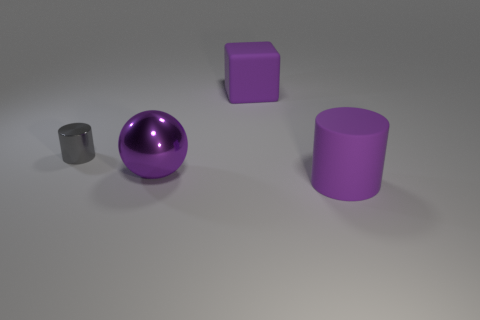How many objects are there, and can you describe their shapes? There are four objects in total. Starting from the left, there's a small matte grey cylinder, a shiny purple sphere, a smaller matte purple cube, and a larger matte purple cylinder. 